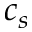<formula> <loc_0><loc_0><loc_500><loc_500>c _ { s }</formula> 